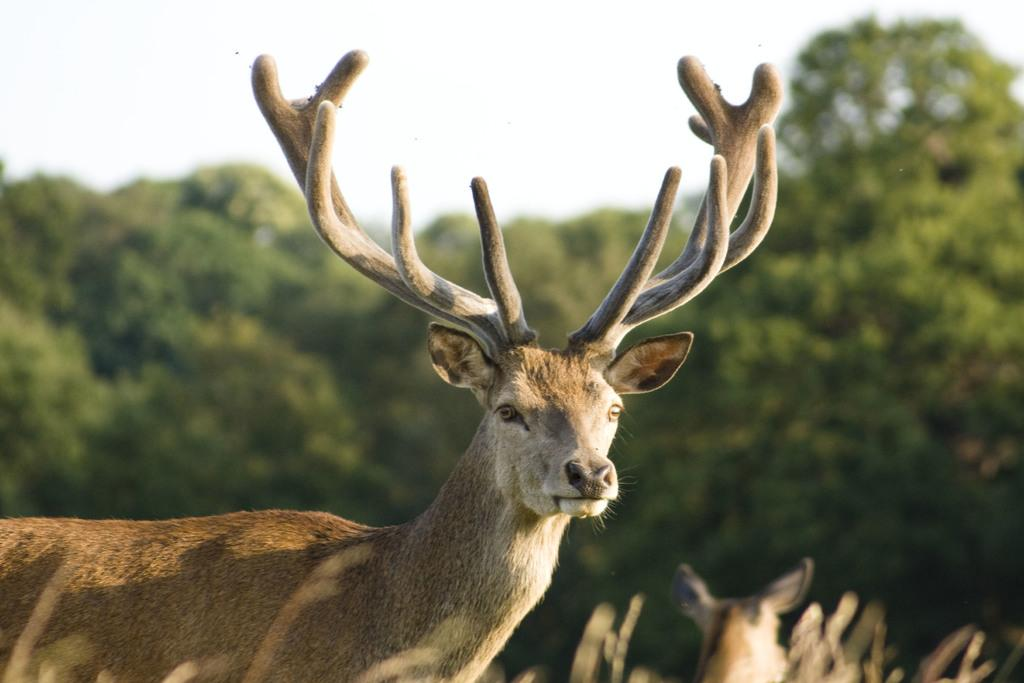What animal is the main subject of the picture? There is an antelope in the picture. How would you describe the background of the image? The background of the image is blurred. What type of vegetation can be seen in the background? There are trees in the background of the image. What is the weather like in the image? The weather is sunny. What type of club is being used to harvest crops in the plantation shown in the image? There is no club or plantation present in the image; it features an antelope with a blurred background and sunny weather. 